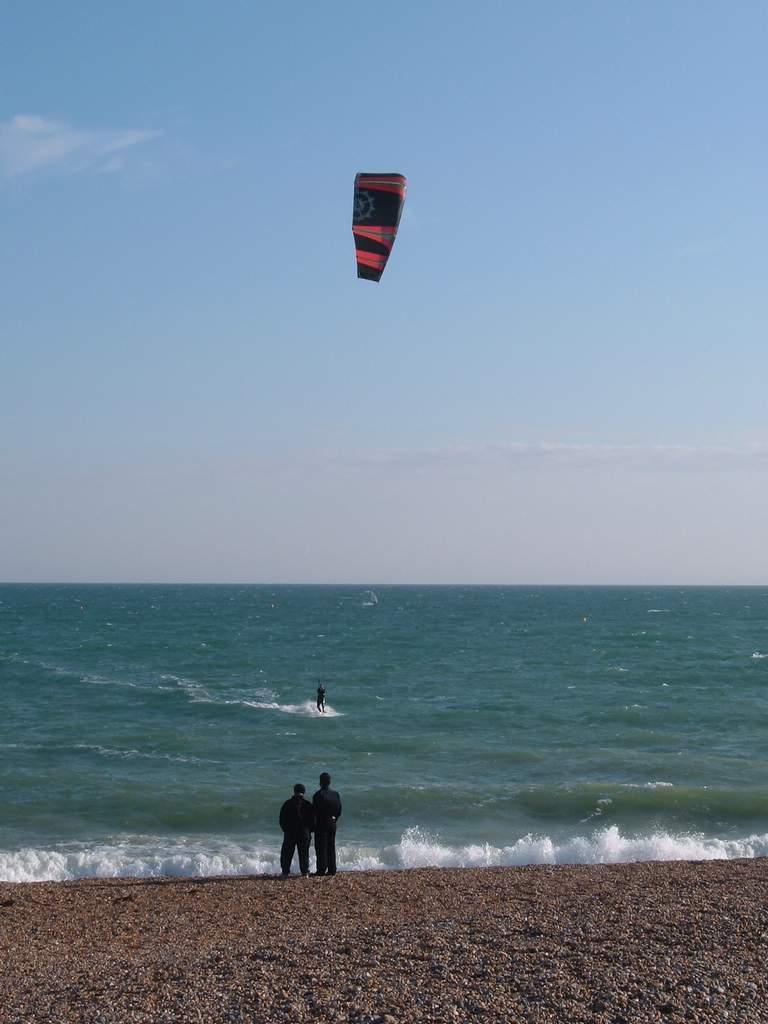How would you summarize this image in a sentence or two? There are two persons standing on the sea shore. In the background there is water. And there is a person on the water. There is a balloon in the air. In the background there is sky. 